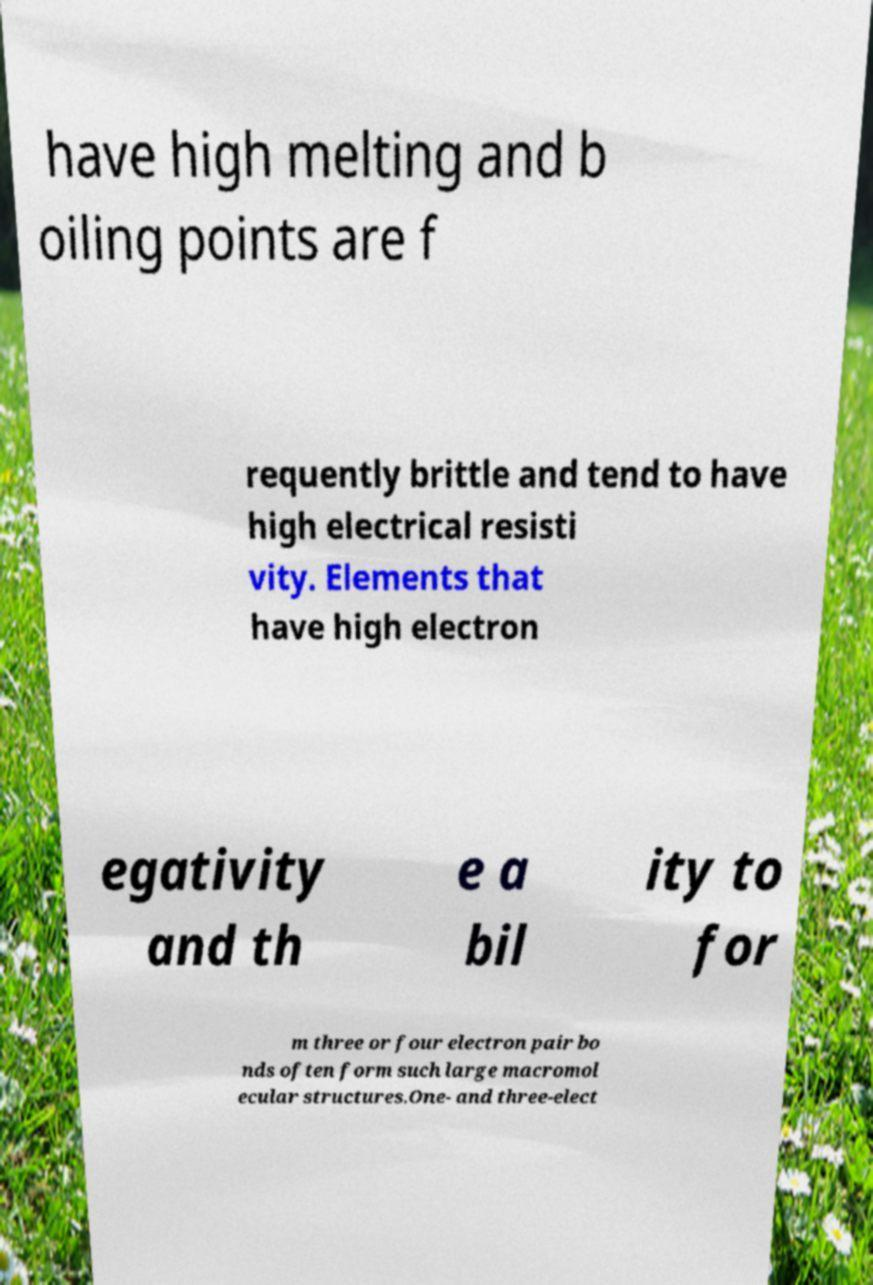Can you read and provide the text displayed in the image?This photo seems to have some interesting text. Can you extract and type it out for me? have high melting and b oiling points are f requently brittle and tend to have high electrical resisti vity. Elements that have high electron egativity and th e a bil ity to for m three or four electron pair bo nds often form such large macromol ecular structures.One- and three-elect 